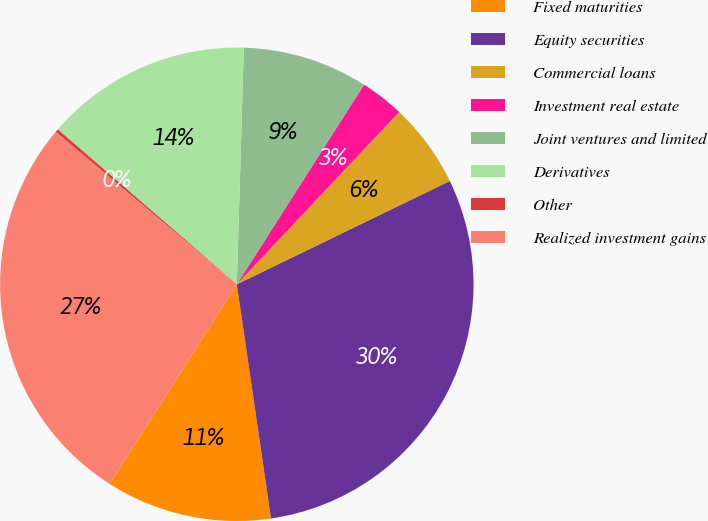<chart> <loc_0><loc_0><loc_500><loc_500><pie_chart><fcel>Fixed maturities<fcel>Equity securities<fcel>Commercial loans<fcel>Investment real estate<fcel>Joint ventures and limited<fcel>Derivatives<fcel>Other<fcel>Realized investment gains<nl><fcel>11.34%<fcel>29.88%<fcel>5.78%<fcel>3.0%<fcel>8.56%<fcel>14.12%<fcel>0.22%<fcel>27.1%<nl></chart> 